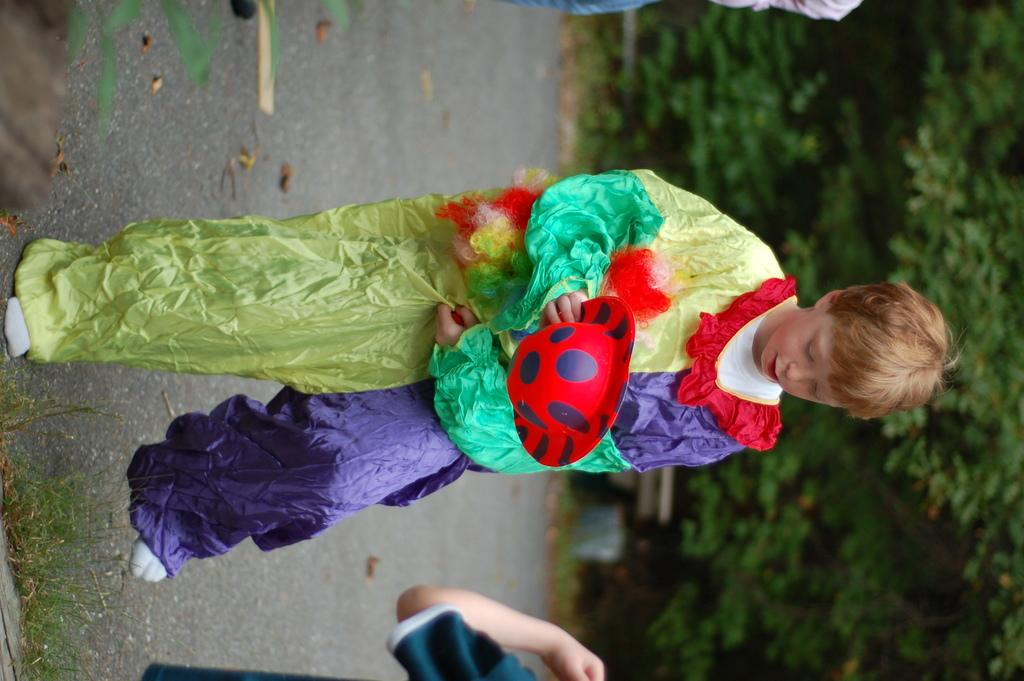Who is the main subject in the image? There is a boy in the image. What is the boy wearing or doing in the image? The boy is in costume. What can be seen on the right side of the image? There are trees on the right side of the image. What part of a human is visible at the bottom of the image? There is a hand of a human at the bottom of the image. How many beads are hanging from the branches in the image? There are no beads or branches present in the image. What type of snails can be seen crawling on the boy's costume in the image? There are no snails visible in the image; the boy is wearing a costume. 